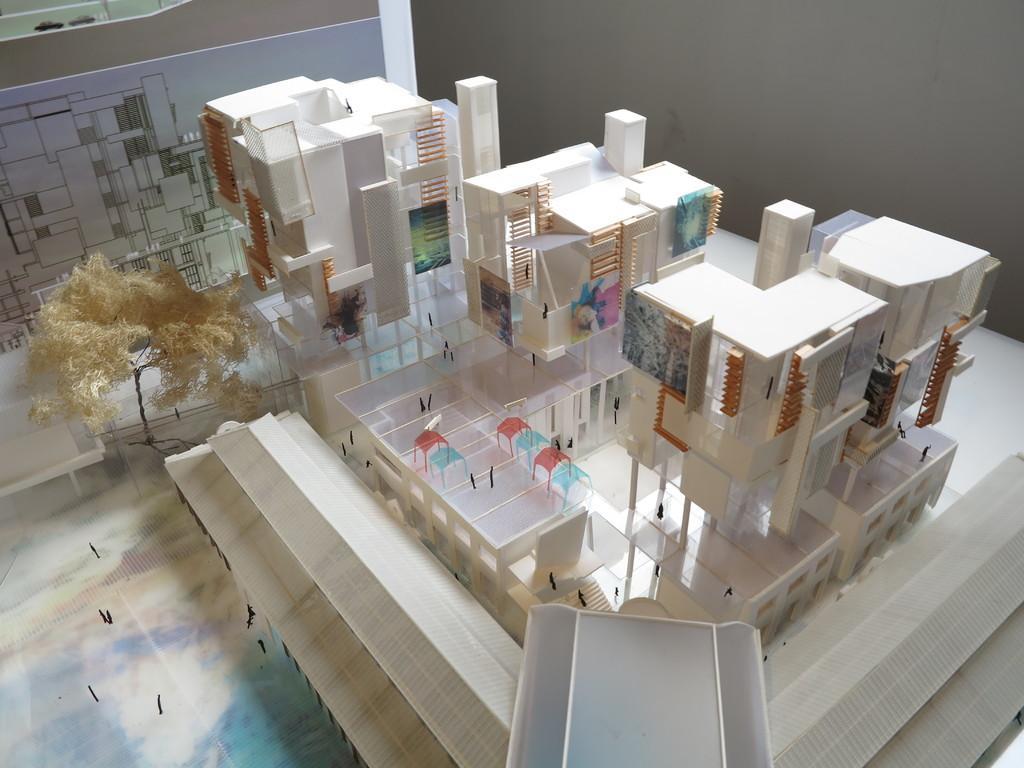Could you give a brief overview of what you see in this image? In this picture I can see the model of the buildings, chairs and other objects. On the left I can see the design in the paper which is placed on the wall. 